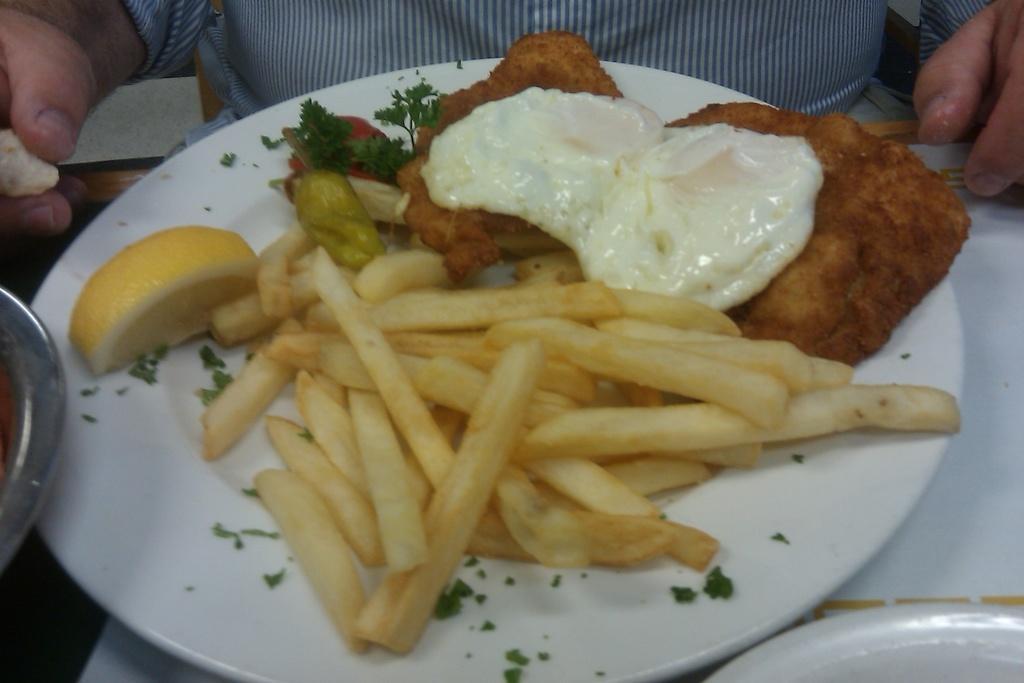What is present on the plate in the image? There are food items in a plate in the image. Can you describe any other elements in the image? Yes, there are hands of a person visible in the image. What type of sack can be seen in the image? There is no sack present in the image. What is the tendency of the cable in the image? There is no cable present in the image. 